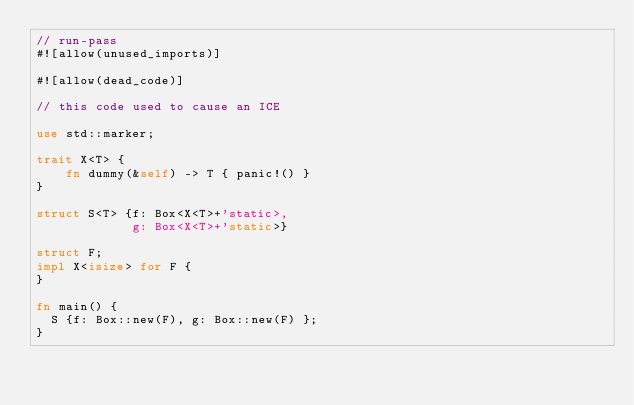<code> <loc_0><loc_0><loc_500><loc_500><_Rust_>// run-pass
#![allow(unused_imports)]

#![allow(dead_code)]

// this code used to cause an ICE

use std::marker;

trait X<T> {
    fn dummy(&self) -> T { panic!() }
}

struct S<T> {f: Box<X<T>+'static>,
             g: Box<X<T>+'static>}

struct F;
impl X<isize> for F {
}

fn main() {
  S {f: Box::new(F), g: Box::new(F) };
}
</code> 